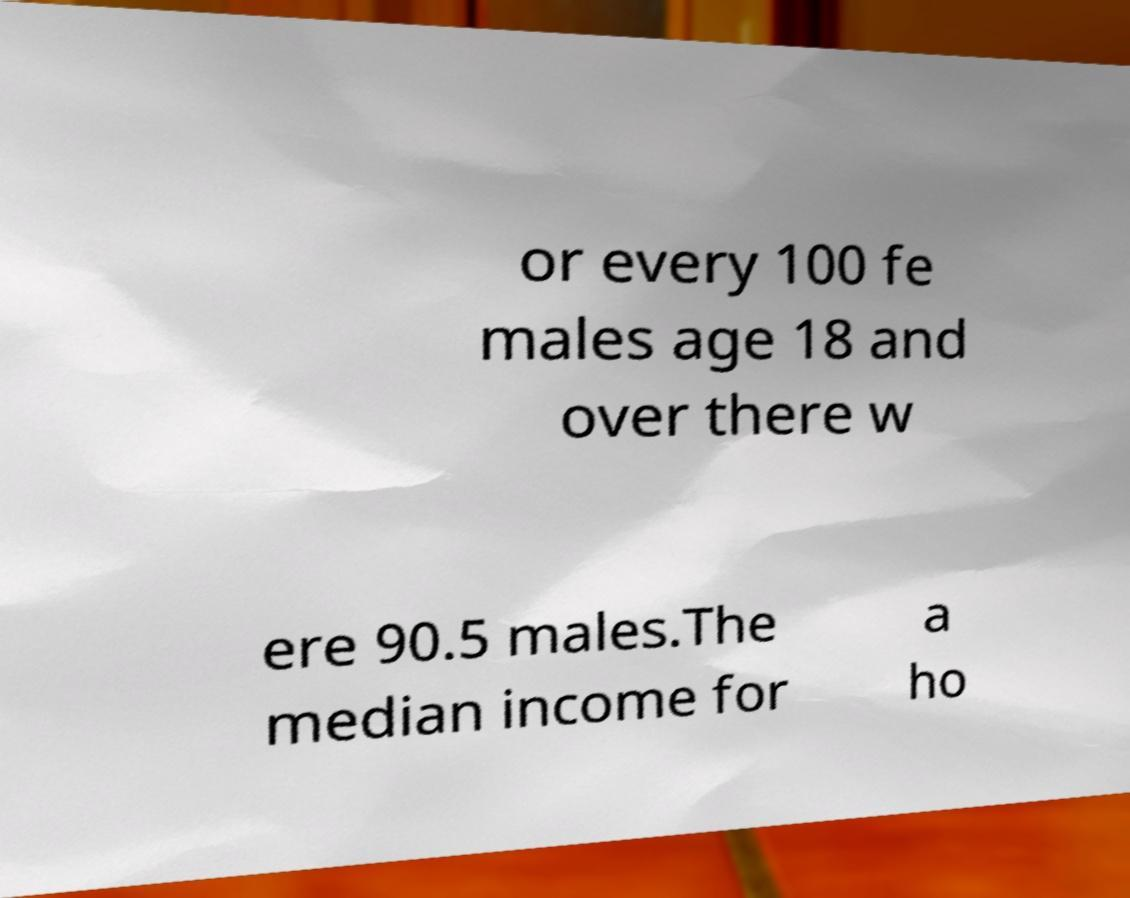Please identify and transcribe the text found in this image. or every 100 fe males age 18 and over there w ere 90.5 males.The median income for a ho 